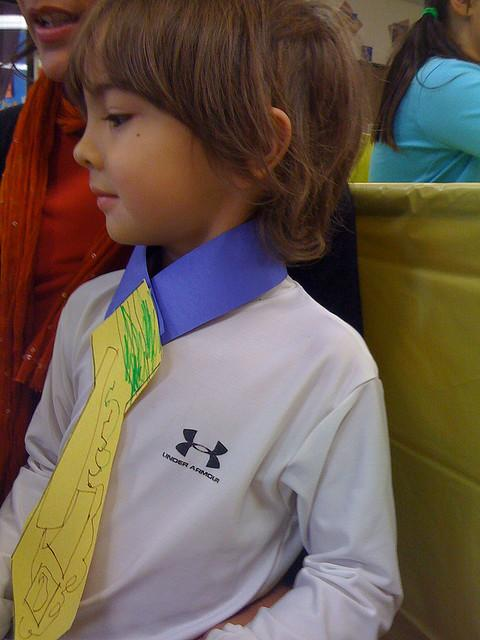What is the small child's tie made out of? Please explain your reasoning. paper. The tie is made of paper. 